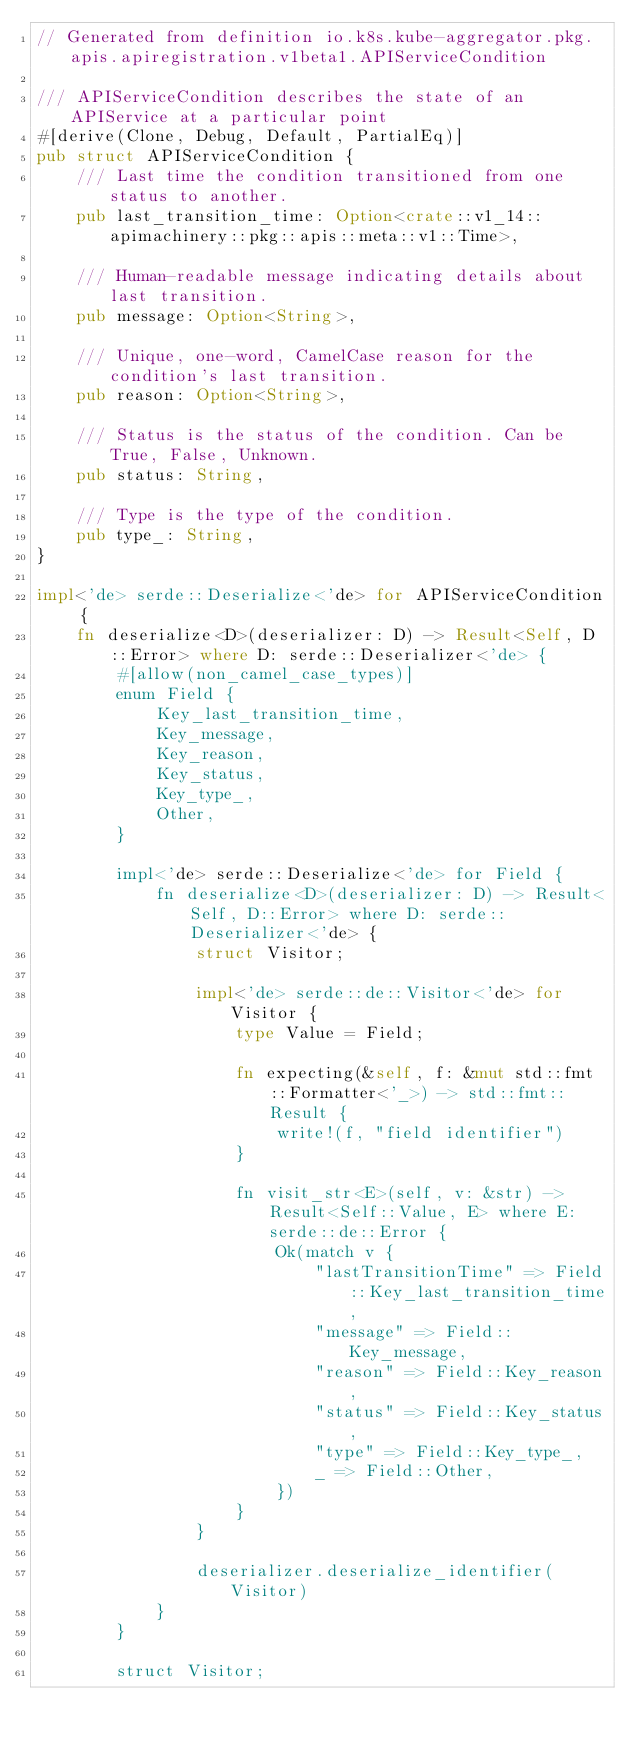<code> <loc_0><loc_0><loc_500><loc_500><_Rust_>// Generated from definition io.k8s.kube-aggregator.pkg.apis.apiregistration.v1beta1.APIServiceCondition

/// APIServiceCondition describes the state of an APIService at a particular point
#[derive(Clone, Debug, Default, PartialEq)]
pub struct APIServiceCondition {
    /// Last time the condition transitioned from one status to another.
    pub last_transition_time: Option<crate::v1_14::apimachinery::pkg::apis::meta::v1::Time>,

    /// Human-readable message indicating details about last transition.
    pub message: Option<String>,

    /// Unique, one-word, CamelCase reason for the condition's last transition.
    pub reason: Option<String>,

    /// Status is the status of the condition. Can be True, False, Unknown.
    pub status: String,

    /// Type is the type of the condition.
    pub type_: String,
}

impl<'de> serde::Deserialize<'de> for APIServiceCondition {
    fn deserialize<D>(deserializer: D) -> Result<Self, D::Error> where D: serde::Deserializer<'de> {
        #[allow(non_camel_case_types)]
        enum Field {
            Key_last_transition_time,
            Key_message,
            Key_reason,
            Key_status,
            Key_type_,
            Other,
        }

        impl<'de> serde::Deserialize<'de> for Field {
            fn deserialize<D>(deserializer: D) -> Result<Self, D::Error> where D: serde::Deserializer<'de> {
                struct Visitor;

                impl<'de> serde::de::Visitor<'de> for Visitor {
                    type Value = Field;

                    fn expecting(&self, f: &mut std::fmt::Formatter<'_>) -> std::fmt::Result {
                        write!(f, "field identifier")
                    }

                    fn visit_str<E>(self, v: &str) -> Result<Self::Value, E> where E: serde::de::Error {
                        Ok(match v {
                            "lastTransitionTime" => Field::Key_last_transition_time,
                            "message" => Field::Key_message,
                            "reason" => Field::Key_reason,
                            "status" => Field::Key_status,
                            "type" => Field::Key_type_,
                            _ => Field::Other,
                        })
                    }
                }

                deserializer.deserialize_identifier(Visitor)
            }
        }

        struct Visitor;
</code> 